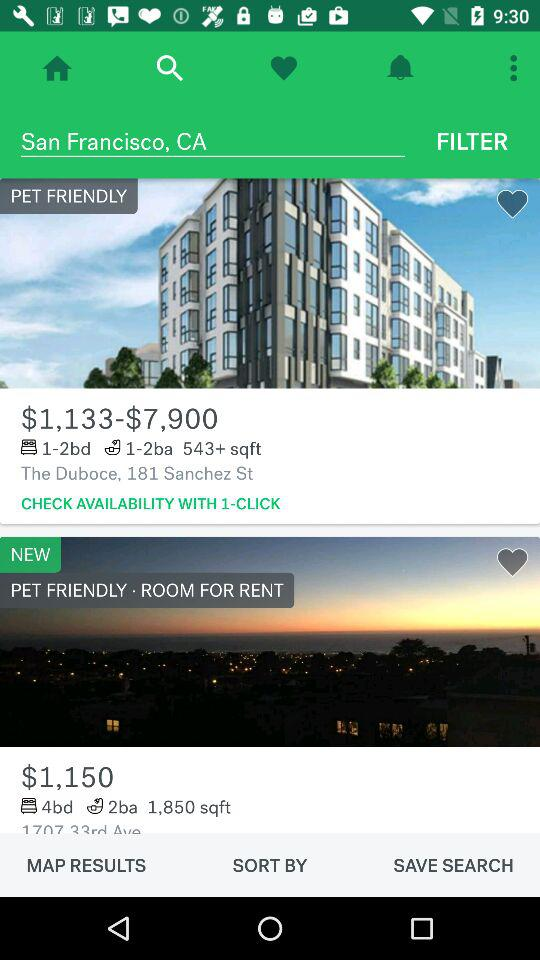What is the location for which rooms are searched? The location for which rooms are searched is San Francisco, CA. 